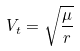Convert formula to latex. <formula><loc_0><loc_0><loc_500><loc_500>V _ { t } = \sqrt { \frac { \mu } { r } }</formula> 